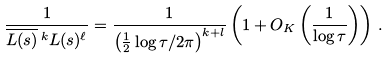Convert formula to latex. <formula><loc_0><loc_0><loc_500><loc_500>\frac { 1 } { \overline { L ( s ) } \, ^ { k } L ( s ) ^ { \ell } } = \frac { 1 } { \left ( \frac { 1 } { 2 } \log \tau / 2 \pi \right ) ^ { k + l } } \left ( 1 + O _ { K } \left ( \frac { 1 } { \log \tau } \right ) \right ) \, .</formula> 